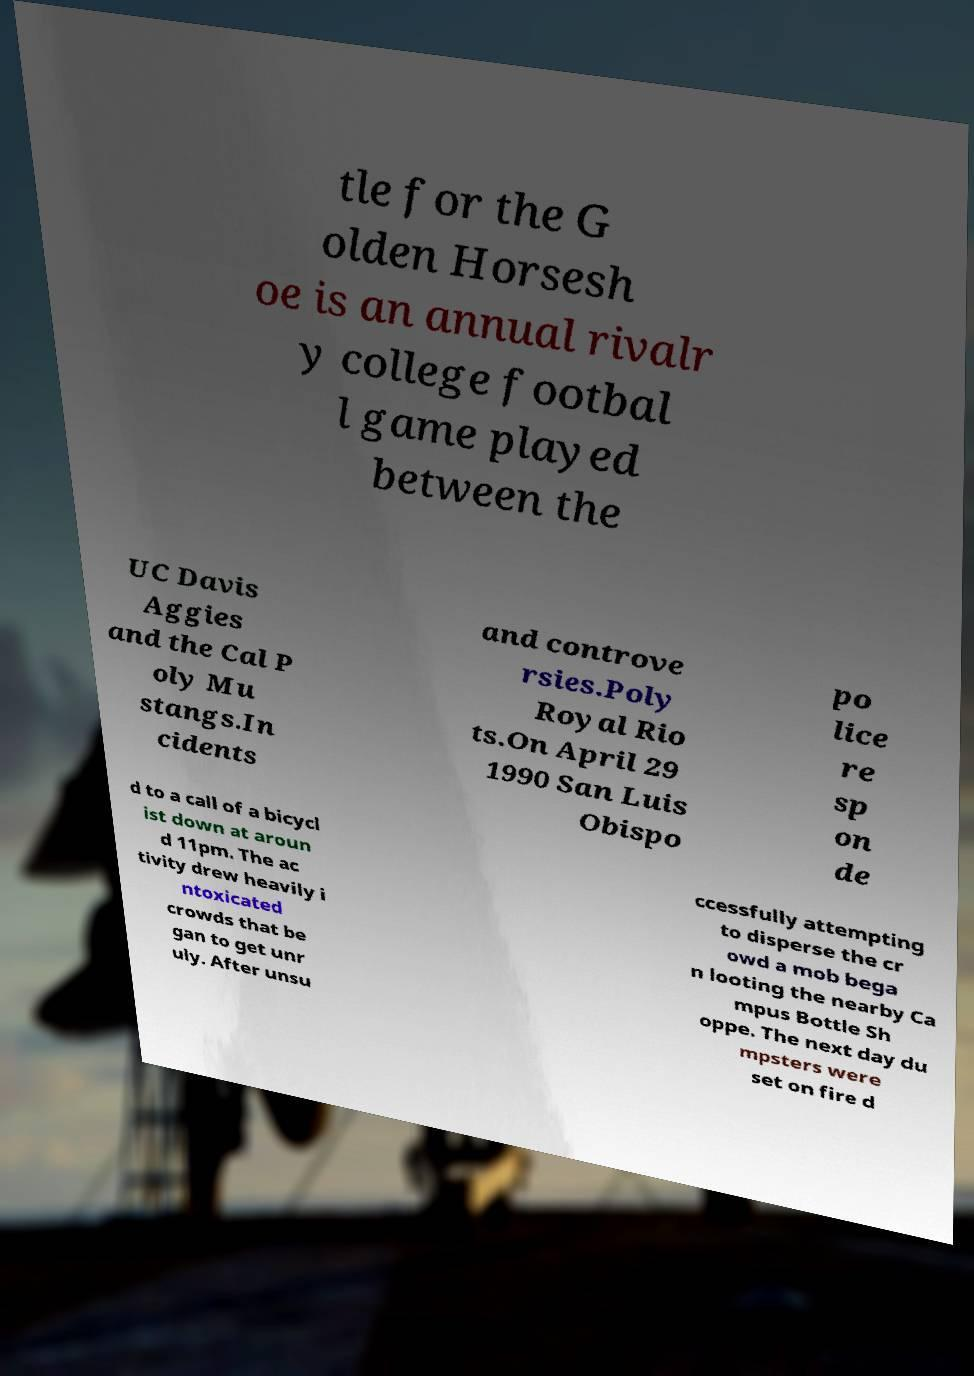Could you assist in decoding the text presented in this image and type it out clearly? tle for the G olden Horsesh oe is an annual rivalr y college footbal l game played between the UC Davis Aggies and the Cal P oly Mu stangs.In cidents and controve rsies.Poly Royal Rio ts.On April 29 1990 San Luis Obispo po lice re sp on de d to a call of a bicycl ist down at aroun d 11pm. The ac tivity drew heavily i ntoxicated crowds that be gan to get unr uly. After unsu ccessfully attempting to disperse the cr owd a mob bega n looting the nearby Ca mpus Bottle Sh oppe. The next day du mpsters were set on fire d 